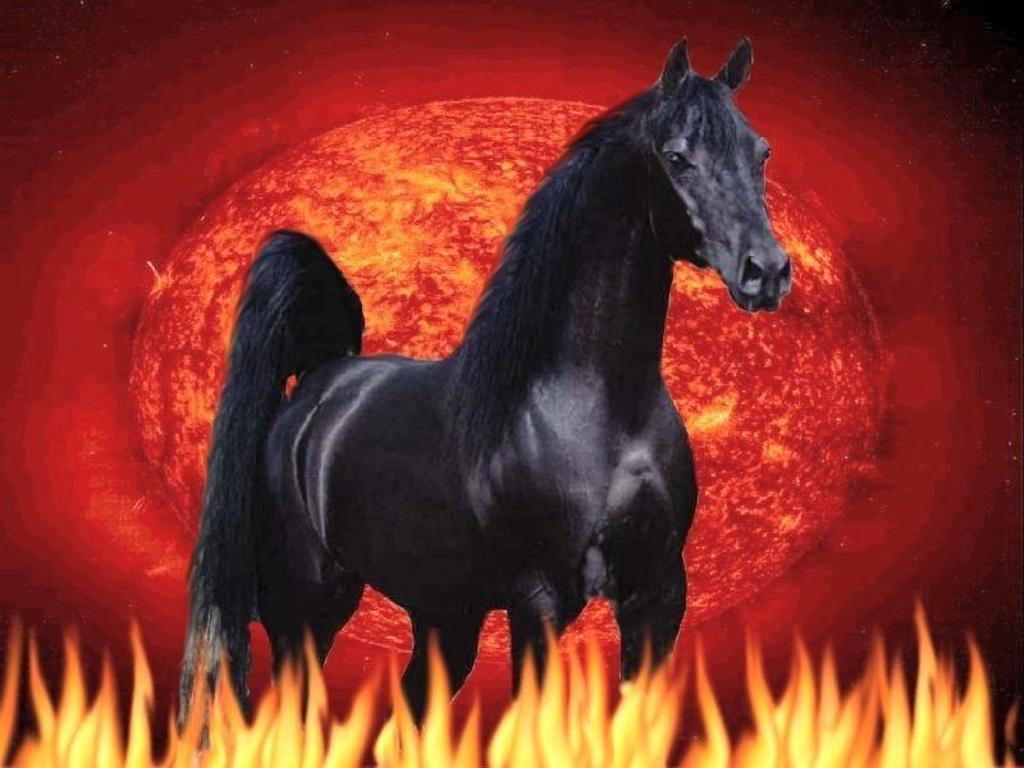How would you summarize this image in a sentence or two? This is an animated image , where there is a black color horse , fire , and there is red color background. 